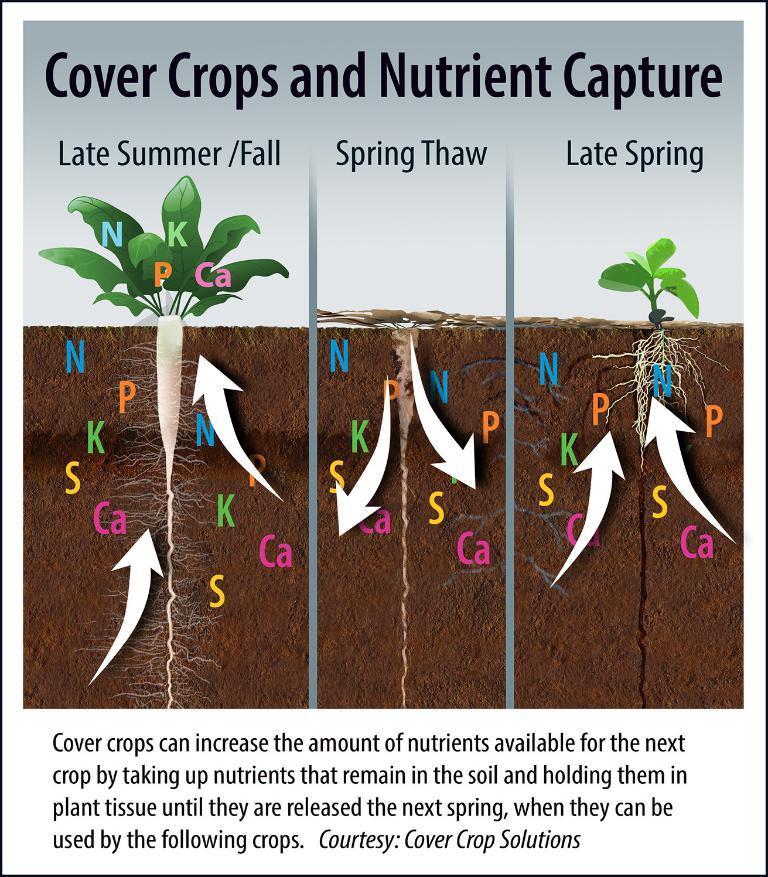How would you summarize this image in a sentence or two? As we can see in the image there is a paper. On paper there is drawing of plant, roots and there is something written. 